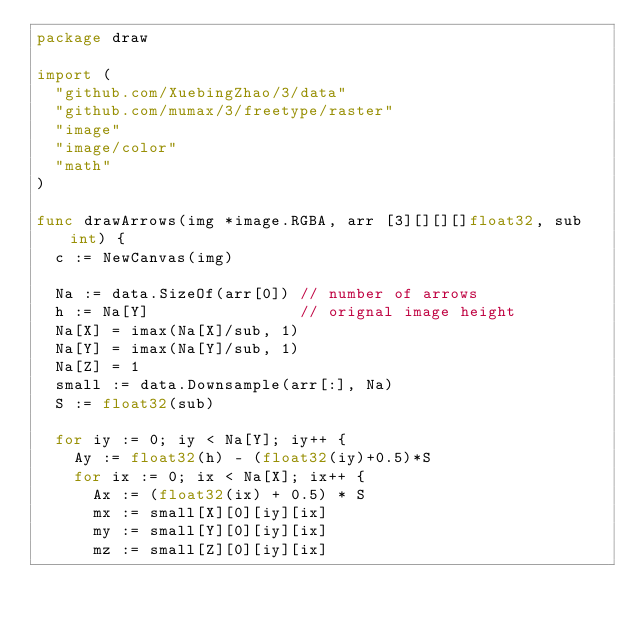<code> <loc_0><loc_0><loc_500><loc_500><_Go_>package draw

import (
	"github.com/XuebingZhao/3/data"
	"github.com/mumax/3/freetype/raster"
	"image"
	"image/color"
	"math"
)

func drawArrows(img *image.RGBA, arr [3][][][]float32, sub int) {
	c := NewCanvas(img)

	Na := data.SizeOf(arr[0]) // number of arrows
	h := Na[Y]                // orignal image height
	Na[X] = imax(Na[X]/sub, 1)
	Na[Y] = imax(Na[Y]/sub, 1)
	Na[Z] = 1
	small := data.Downsample(arr[:], Na)
	S := float32(sub)

	for iy := 0; iy < Na[Y]; iy++ {
		Ay := float32(h) - (float32(iy)+0.5)*S
		for ix := 0; ix < Na[X]; ix++ {
			Ax := (float32(ix) + 0.5) * S
			mx := small[X][0][iy][ix]
			my := small[Y][0][iy][ix]
			mz := small[Z][0][iy][ix]</code> 